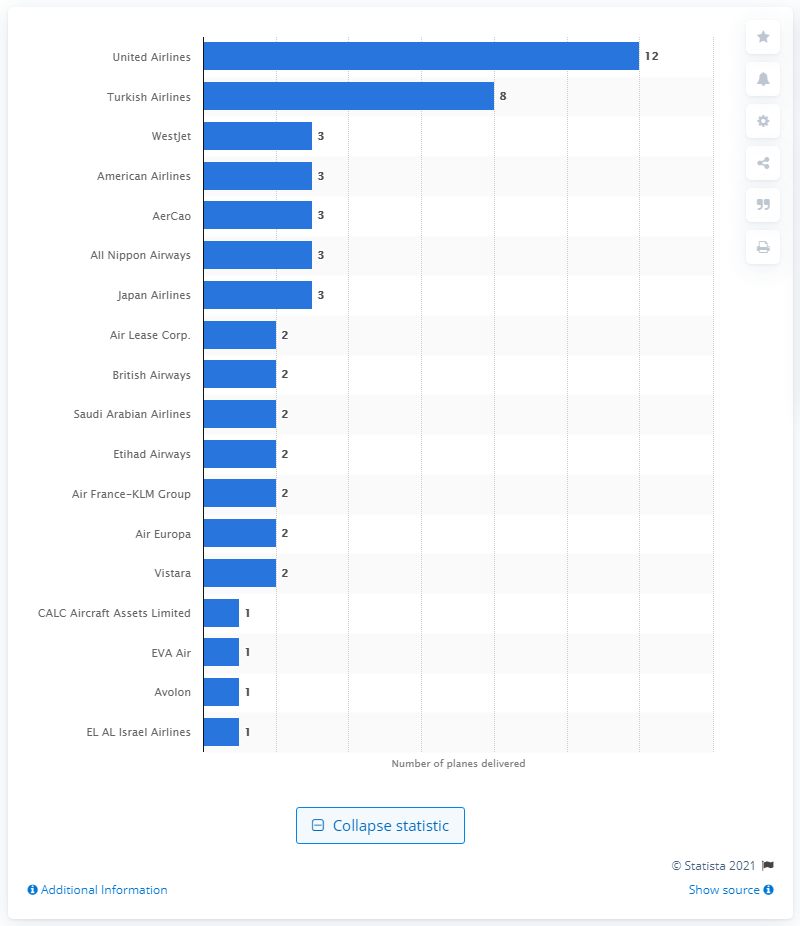Outline some significant characteristics in this image. The Boeing 787's debut airline was All Nippon Airways. 